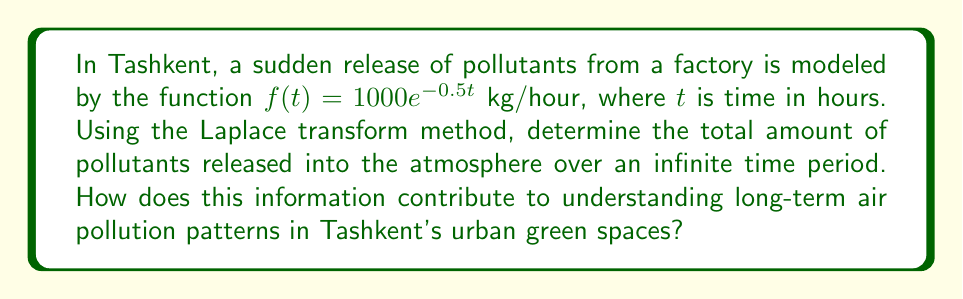Provide a solution to this math problem. To solve this problem, we'll use the Laplace transform method:

1) The Laplace transform of $f(t) = 1000e^{-0.5t}$ is given by:

   $$F(s) = \mathcal{L}\{f(t)\} = \int_0^\infty 1000e^{-0.5t}e^{-st}dt$$

2) Simplify the integral:

   $$F(s) = 1000\int_0^\infty e^{-(s+0.5)t}dt$$

3) Solve the integral:

   $$F(s) = 1000\left[-\frac{1}{s+0.5}e^{-(s+0.5)t}\right]_0^\infty = \frac{1000}{s+0.5}$$

4) To find the total amount of pollutants released, we need to evaluate $\lim_{s \to 0} sF(s)$:

   $$\lim_{s \to 0} sF(s) = \lim_{s \to 0} \frac{1000s}{s+0.5} = 2000\text{ kg}$$

This result shows that the total amount of pollutants released over an infinite time period is 2000 kg.

Understanding this long-term pollution output is crucial for environmental conservationists in Tashkent. It helps in:

1) Assessing the cumulative impact on urban green spaces over time.
2) Planning appropriate mitigation strategies for air pollution in the city.
3) Determining the carrying capacity of local ecosystems and their ability to absorb pollutants.
4) Informing policy decisions on industrial emissions and urban green space development.
Answer: The total amount of pollutants released into the atmosphere over an infinite time period is 2000 kg. 